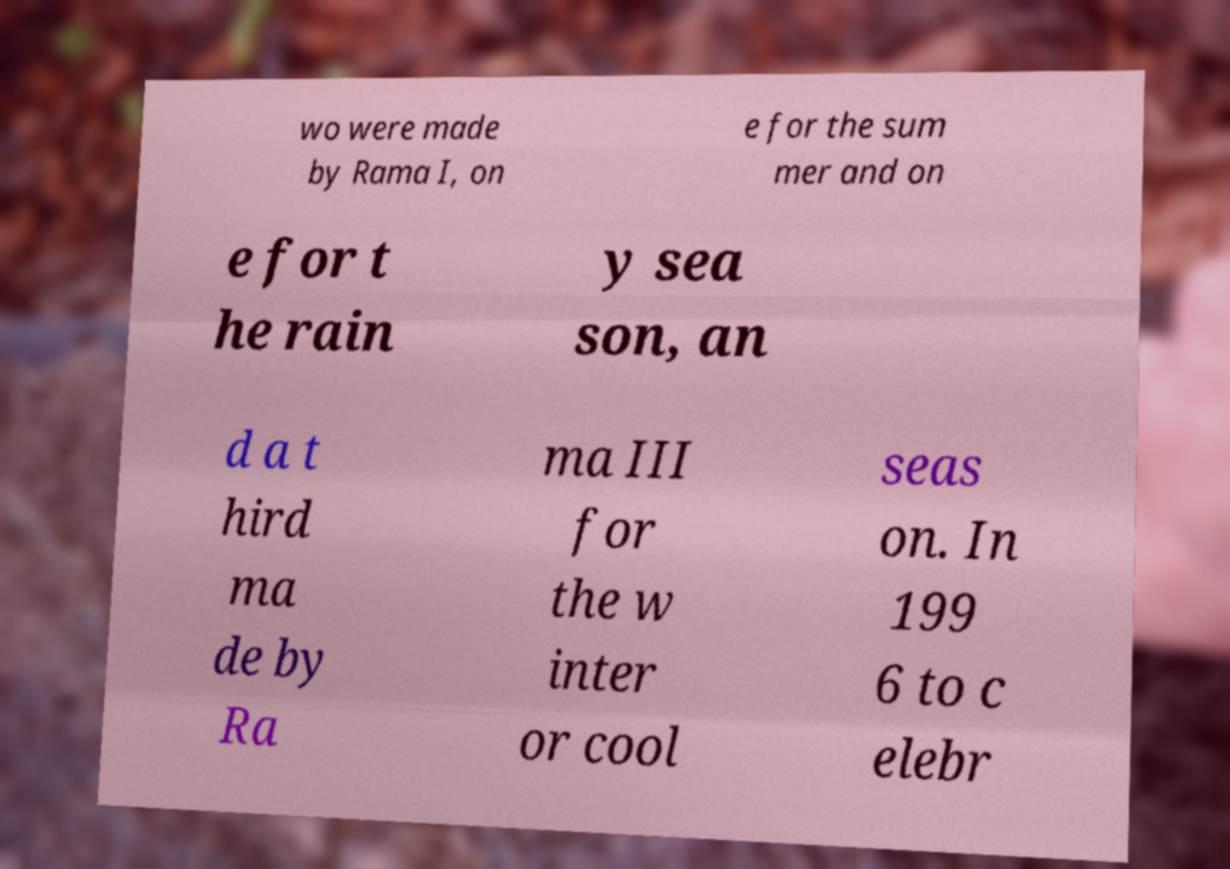I need the written content from this picture converted into text. Can you do that? wo were made by Rama I, on e for the sum mer and on e for t he rain y sea son, an d a t hird ma de by Ra ma III for the w inter or cool seas on. In 199 6 to c elebr 